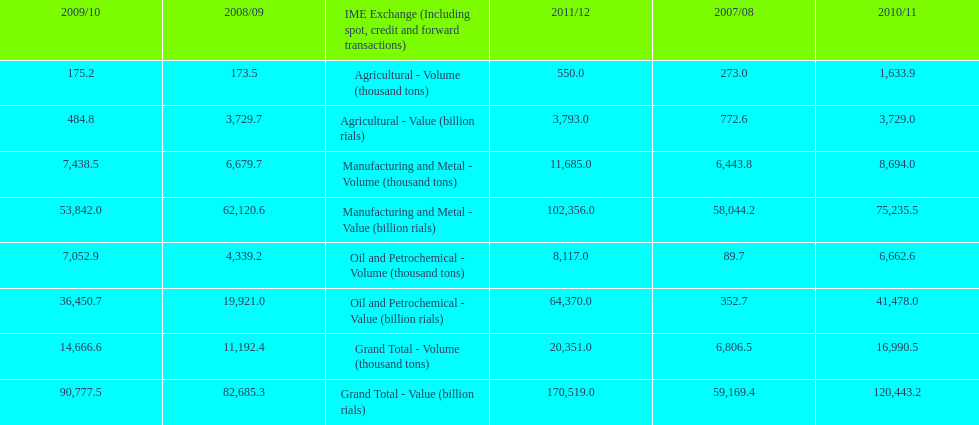Which year had the largest agricultural volume? 2010/11. 